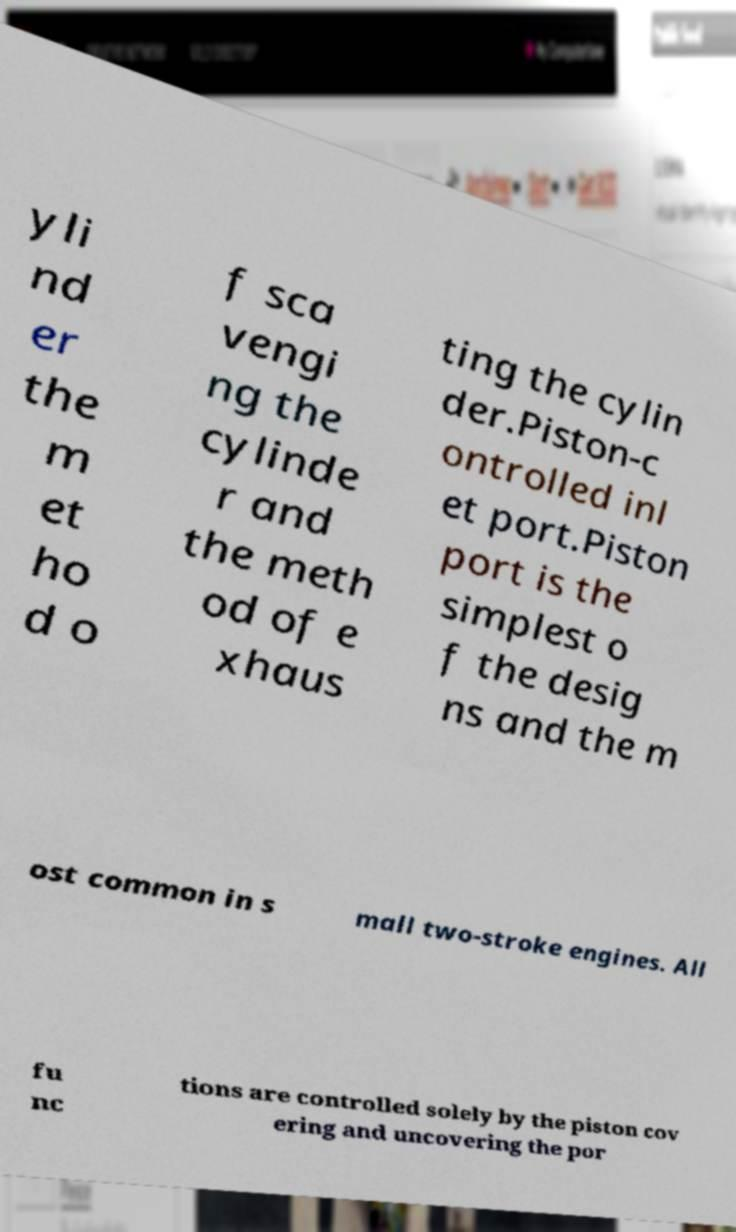For documentation purposes, I need the text within this image transcribed. Could you provide that? yli nd er the m et ho d o f sca vengi ng the cylinde r and the meth od of e xhaus ting the cylin der.Piston-c ontrolled inl et port.Piston port is the simplest o f the desig ns and the m ost common in s mall two-stroke engines. All fu nc tions are controlled solely by the piston cov ering and uncovering the por 